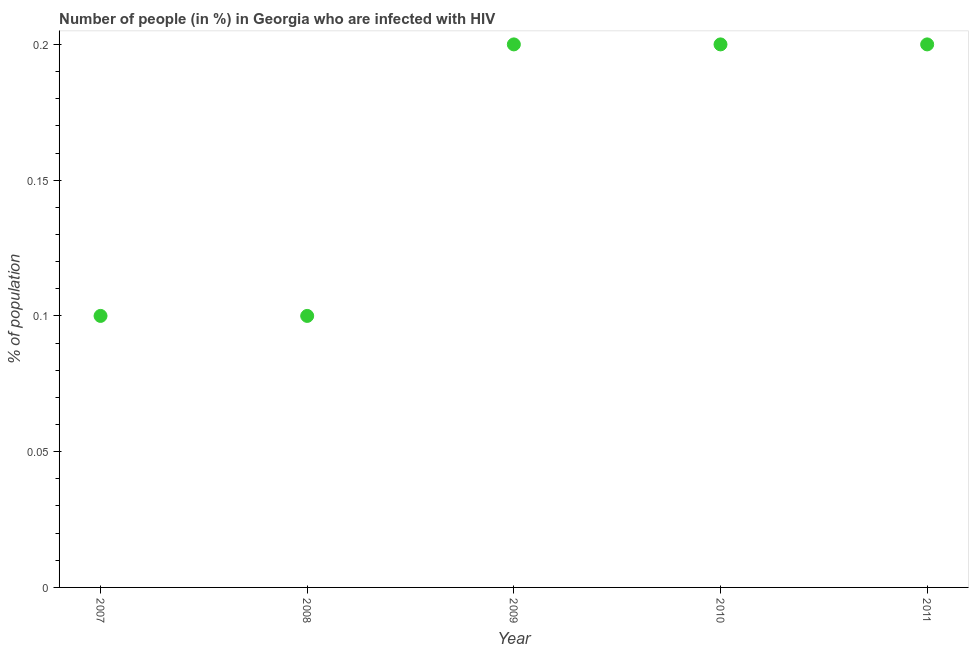What is the number of people infected with hiv in 2007?
Make the answer very short. 0.1. Across all years, what is the minimum number of people infected with hiv?
Your answer should be compact. 0.1. In which year was the number of people infected with hiv minimum?
Provide a short and direct response. 2007. What is the sum of the number of people infected with hiv?
Your answer should be compact. 0.8. What is the difference between the number of people infected with hiv in 2009 and 2011?
Offer a very short reply. 0. What is the average number of people infected with hiv per year?
Provide a succinct answer. 0.16. What is the median number of people infected with hiv?
Ensure brevity in your answer.  0.2. Do a majority of the years between 2009 and 2010 (inclusive) have number of people infected with hiv greater than 0.04 %?
Your answer should be compact. Yes. What is the ratio of the number of people infected with hiv in 2008 to that in 2010?
Your answer should be compact. 0.5. Is the difference between the number of people infected with hiv in 2009 and 2010 greater than the difference between any two years?
Your answer should be compact. No. How many years are there in the graph?
Provide a short and direct response. 5. What is the difference between two consecutive major ticks on the Y-axis?
Provide a short and direct response. 0.05. Are the values on the major ticks of Y-axis written in scientific E-notation?
Give a very brief answer. No. What is the title of the graph?
Keep it short and to the point. Number of people (in %) in Georgia who are infected with HIV. What is the label or title of the X-axis?
Make the answer very short. Year. What is the label or title of the Y-axis?
Offer a very short reply. % of population. What is the % of population in 2007?
Your answer should be compact. 0.1. What is the % of population in 2008?
Offer a very short reply. 0.1. What is the % of population in 2010?
Keep it short and to the point. 0.2. What is the % of population in 2011?
Keep it short and to the point. 0.2. What is the difference between the % of population in 2007 and 2008?
Give a very brief answer. 0. What is the difference between the % of population in 2008 and 2009?
Ensure brevity in your answer.  -0.1. What is the difference between the % of population in 2008 and 2011?
Give a very brief answer. -0.1. What is the difference between the % of population in 2009 and 2010?
Make the answer very short. 0. What is the difference between the % of population in 2010 and 2011?
Provide a short and direct response. 0. What is the ratio of the % of population in 2007 to that in 2008?
Offer a terse response. 1. What is the ratio of the % of population in 2007 to that in 2010?
Provide a short and direct response. 0.5. What is the ratio of the % of population in 2008 to that in 2009?
Offer a terse response. 0.5. What is the ratio of the % of population in 2009 to that in 2011?
Provide a short and direct response. 1. 